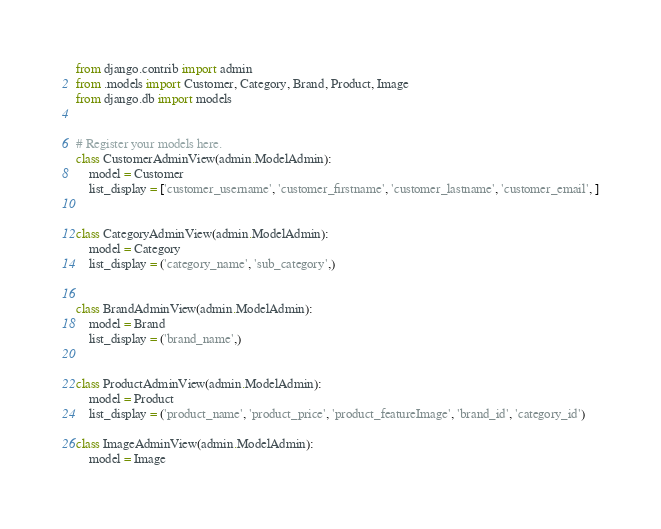<code> <loc_0><loc_0><loc_500><loc_500><_Python_>from django.contrib import admin
from .models import Customer, Category, Brand, Product, Image
from django.db import models


# Register your models here.
class CustomerAdminView(admin.ModelAdmin):
    model = Customer
    list_display = ['customer_username', 'customer_firstname', 'customer_lastname', 'customer_email', ]


class CategoryAdminView(admin.ModelAdmin):
    model = Category
    list_display = ('category_name', 'sub_category',)


class BrandAdminView(admin.ModelAdmin):
    model = Brand
    list_display = ('brand_name',)


class ProductAdminView(admin.ModelAdmin):
    model = Product
    list_display = ('product_name', 'product_price', 'product_featureImage', 'brand_id', 'category_id')

class ImageAdminView(admin.ModelAdmin):
    model = Image</code> 